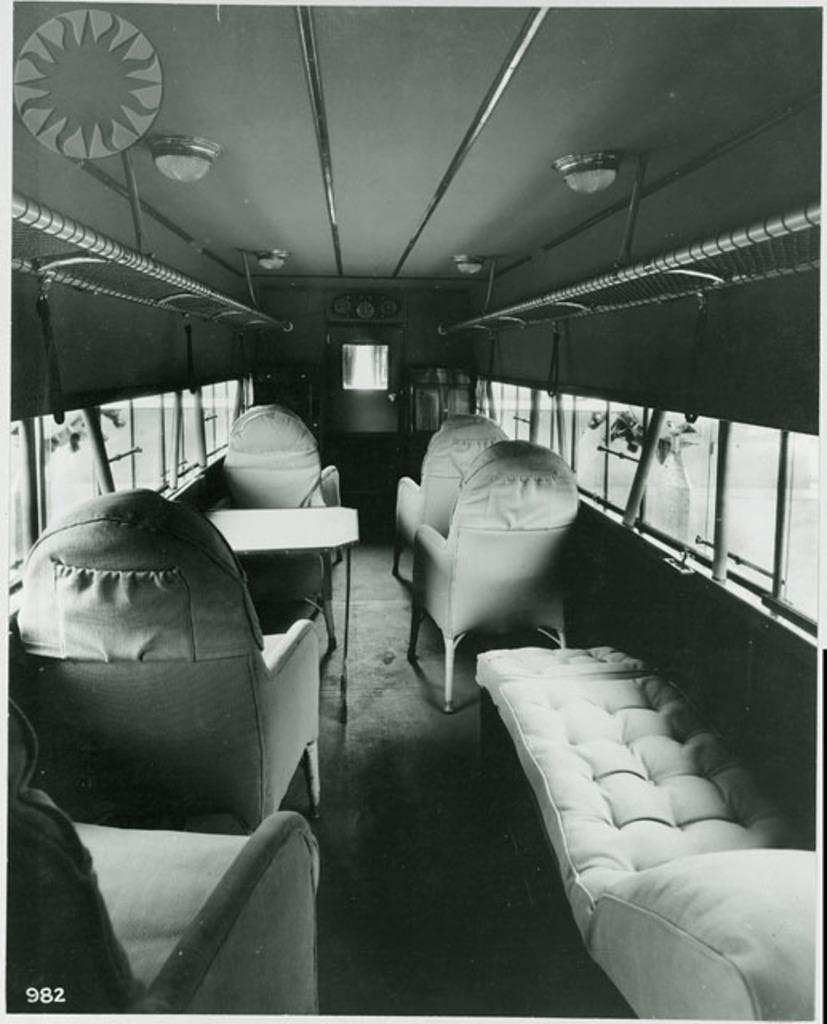What type of vehicle is in the image? There is a vehicle in the image, but the specific type is not mentioned. What type of furniture is in the image? There are chairs, a table, and a sofa in the image. What architectural elements are in the image? There are window glasses, poles, and lights in the image. What can be seen outside the vehicle in the image? There is a tree outside the vehicle in the image. What is the vehicle's reaction to the fear of the grandfather during recess? There is no mention of fear, grandfather, or recess in the image, so this question cannot be answered. 